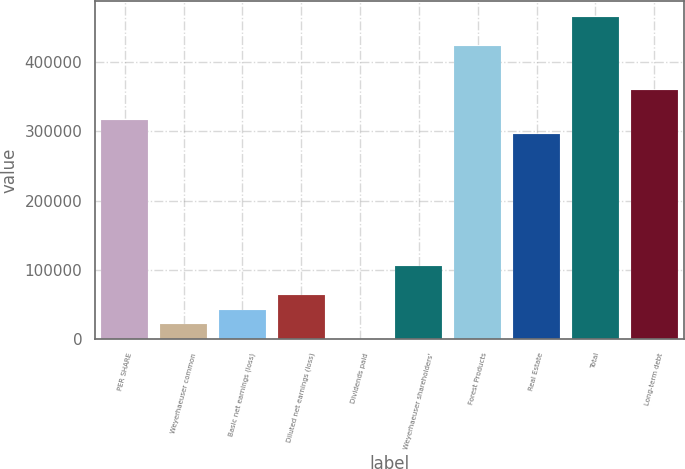<chart> <loc_0><loc_0><loc_500><loc_500><bar_chart><fcel>PER SHARE<fcel>Weyerhaeuser common<fcel>Basic net earnings (loss)<fcel>Diluted net earnings (loss)<fcel>Dividends paid<fcel>Weyerhaeuser shareholders'<fcel>Forest Products<fcel>Real Estate<fcel>Total<fcel>Long-term debt<nl><fcel>317013<fcel>21134.7<fcel>42268.9<fcel>63403<fcel>0.6<fcel>105671<fcel>422683<fcel>295879<fcel>464952<fcel>359281<nl></chart> 